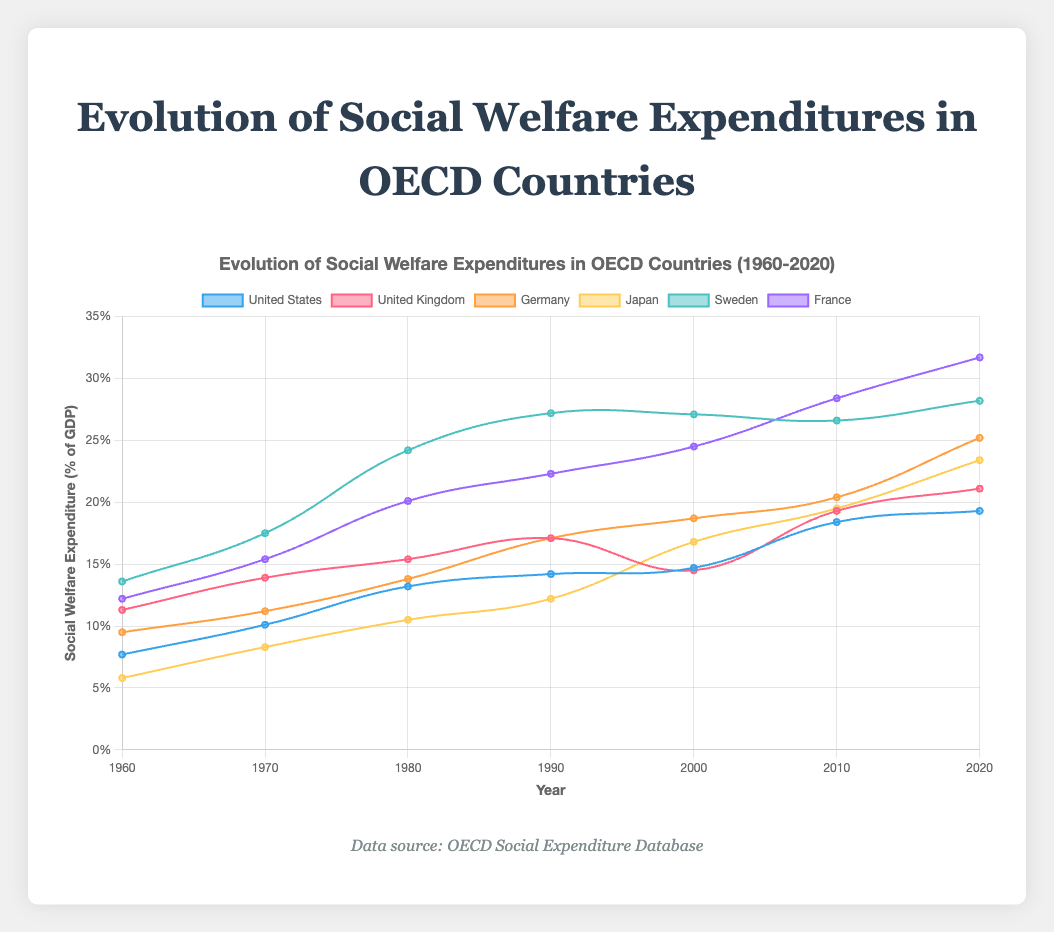What country had the highest social welfare expenditure as a percentage of GDP in 2020? In 2020, observe each country's social welfare expenditure as a percentage of GDP and note the highest value. France has the highest value with 31.7%.
Answer: France Compare the social welfare expenditure of the United States and Japan in 1980. Which country spent more as a percentage of GDP? Locate the values for both the United States and Japan for the year 1980. The United States had 13.2% while Japan had 10.5%. Therefore, the United States spent more.
Answer: United States What is the trend in social welfare expenditures for Sweden from 1960 to 2020? Increase or decrease? Observe Sweden's social welfare expenditure from 1960 to 2020. The values steadily increase from 13.6% in 1960 to 28.2% in 2020, despite minor fluctuations. This indicates an overall increasing trend.
Answer: Increase Calculate the average social welfare expenditure as a percentage of GDP for Germany from 2000 to 2020. Add the values for Germany in 2000, 2010, and 2020, then divide by the number of years: (18.7% + 20.4% + 25.2%) / 3. Therefore, the average is (64.3%) / 3 = 21.43%.
Answer: 21.43% Between 1960 and 2020, which country had the largest increase in social welfare expenditure as a percentage of GDP? Calculate the difference in social welfare expenditure between 1960 and 2020 for each country: 
- United States: 19.3% - 7.7% = 11.6%
- United Kingdom: 21.1% - 11.3% = 9.8%
- Germany: 25.2% - 9.5% = 15.7%
- Japan: 23.4% - 5.8% = 17.6%
- Sweden: 28.2% - 13.6% = 14.6%
- France: 31.7% - 12.2% = 19.5%
France had the largest increase of 19.5%.
Answer: France What is the average social welfare expenditure as a percentage of GDP for all countries in 2020? Add the 2020 values for all countries and divide by the number of countries: (19.3% + 21.1% + 25.2% + 23.4% + 28.2% + 31.7%) / 6. Therefore, the average is (148.9%) / 6 = 24.82%.
Answer: 24.82% Compare the trend of social welfare expenditures for the United Kingdom and Germany from 1990 to 2010. How do their trends differ? Observe the values for the United Kingdom and Germany from 1990 to 2010:
- United Kingdom: 17.1% (1990) to 19.3% (2010), an increase.
- Germany: 17.1% (1990) to 20.4% (2010), also an increase. 
Both countries show an increasing trend, but Germany's increase is steeper.
Answer: Germany's increase is steeper Which country had the smallest social welfare expenditure as a percentage of GDP in 1960? Examine the values for each country in 1960. Japan has the smallest value at 5.8%.
Answer: Japan Compare the changes in social welfare expenditure as a percentage of GDP between 2000 and 2010 for Sweden and France. Which country showed a greater change? Calculate the change in rate for both countries from 2000 to 2010:
- Sweden: 26.6% (2010) - 27.1% (2000) = -0.5%
- France: 28.4% (2010) - 24.5% (2000) = 3.9%
France showed a greater positive change of 3.9%.
Answer: France 